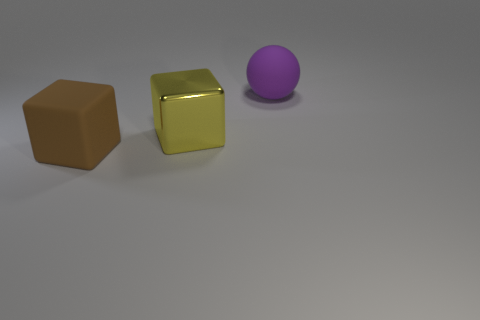What shape is the large rubber thing behind the rubber thing that is in front of the purple matte ball?
Provide a succinct answer. Sphere. What number of things are either blue matte balls or rubber objects behind the large yellow thing?
Offer a terse response. 1. There is another object that is the same shape as the brown object; what is its material?
Your response must be concise. Metal. Are there any other things that have the same material as the big brown thing?
Make the answer very short. Yes. What is the material of the large thing that is both left of the big rubber sphere and behind the brown object?
Give a very brief answer. Metal. How many big yellow things are the same shape as the big brown object?
Offer a terse response. 1. What color is the large block behind the large matte thing that is in front of the purple matte ball?
Give a very brief answer. Yellow. Is the number of blocks to the right of the yellow cube the same as the number of large things?
Make the answer very short. No. Are there any other yellow shiny objects of the same size as the shiny thing?
Give a very brief answer. No. Is the size of the brown matte object the same as the thing behind the yellow shiny object?
Offer a terse response. Yes. 